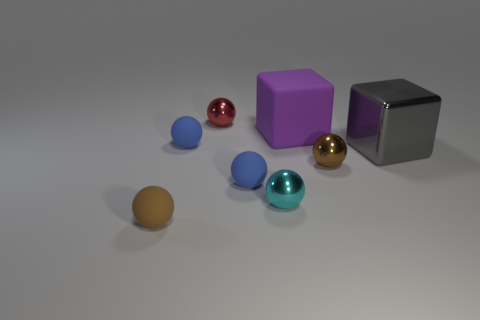Imagine if these objects were part of a game, what could the rules be considering their shapes and colors? If these objects were part of a game, one could imagine a rule set where the different colors and shapes represent distinct game pieces with unique abilities. For example, the spheres could be units that move in any direction, with colors indicating different ranks or powers. The purple cube might serve as a stationary base or home space, while the gray cube could represent a mobile barrier or a wild card piece with variable functions. 